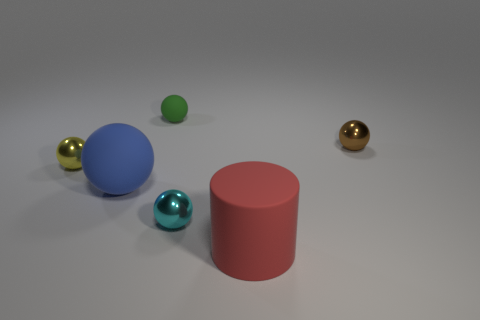Subtract all purple balls. Subtract all red cubes. How many balls are left? 5 Add 3 big spheres. How many objects exist? 9 Subtract all cylinders. How many objects are left? 5 Add 6 green cylinders. How many green cylinders exist? 6 Subtract 0 cyan cubes. How many objects are left? 6 Subtract all yellow spheres. Subtract all small metal objects. How many objects are left? 2 Add 3 small yellow objects. How many small yellow objects are left? 4 